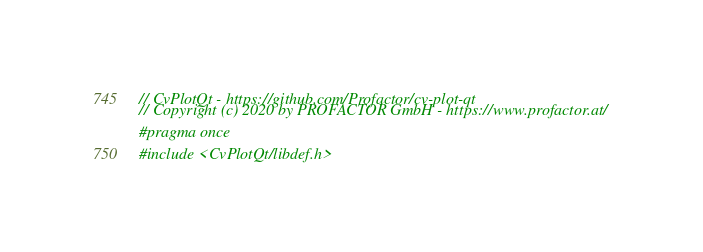<code> <loc_0><loc_0><loc_500><loc_500><_C_>// CvPlotQt - https://github.com/Profactor/cv-plot-qt
// Copyright (c) 2020 by PROFACTOR GmbH - https://www.profactor.at/

#pragma once

#include <CvPlotQt/libdef.h></code> 